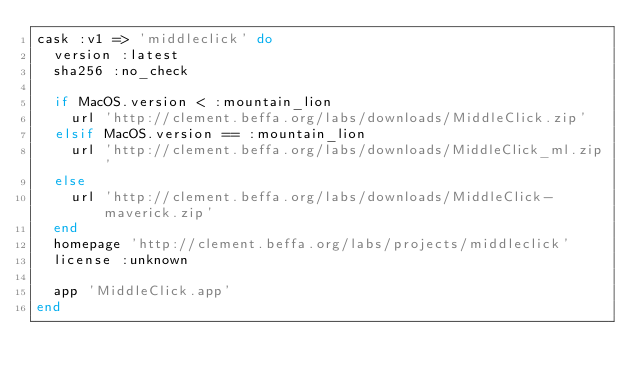<code> <loc_0><loc_0><loc_500><loc_500><_Ruby_>cask :v1 => 'middleclick' do
  version :latest
  sha256 :no_check

  if MacOS.version < :mountain_lion
    url 'http://clement.beffa.org/labs/downloads/MiddleClick.zip'
  elsif MacOS.version == :mountain_lion
    url 'http://clement.beffa.org/labs/downloads/MiddleClick_ml.zip'
  else
    url 'http://clement.beffa.org/labs/downloads/MiddleClick-maverick.zip'
  end
  homepage 'http://clement.beffa.org/labs/projects/middleclick'
  license :unknown

  app 'MiddleClick.app'
end
</code> 